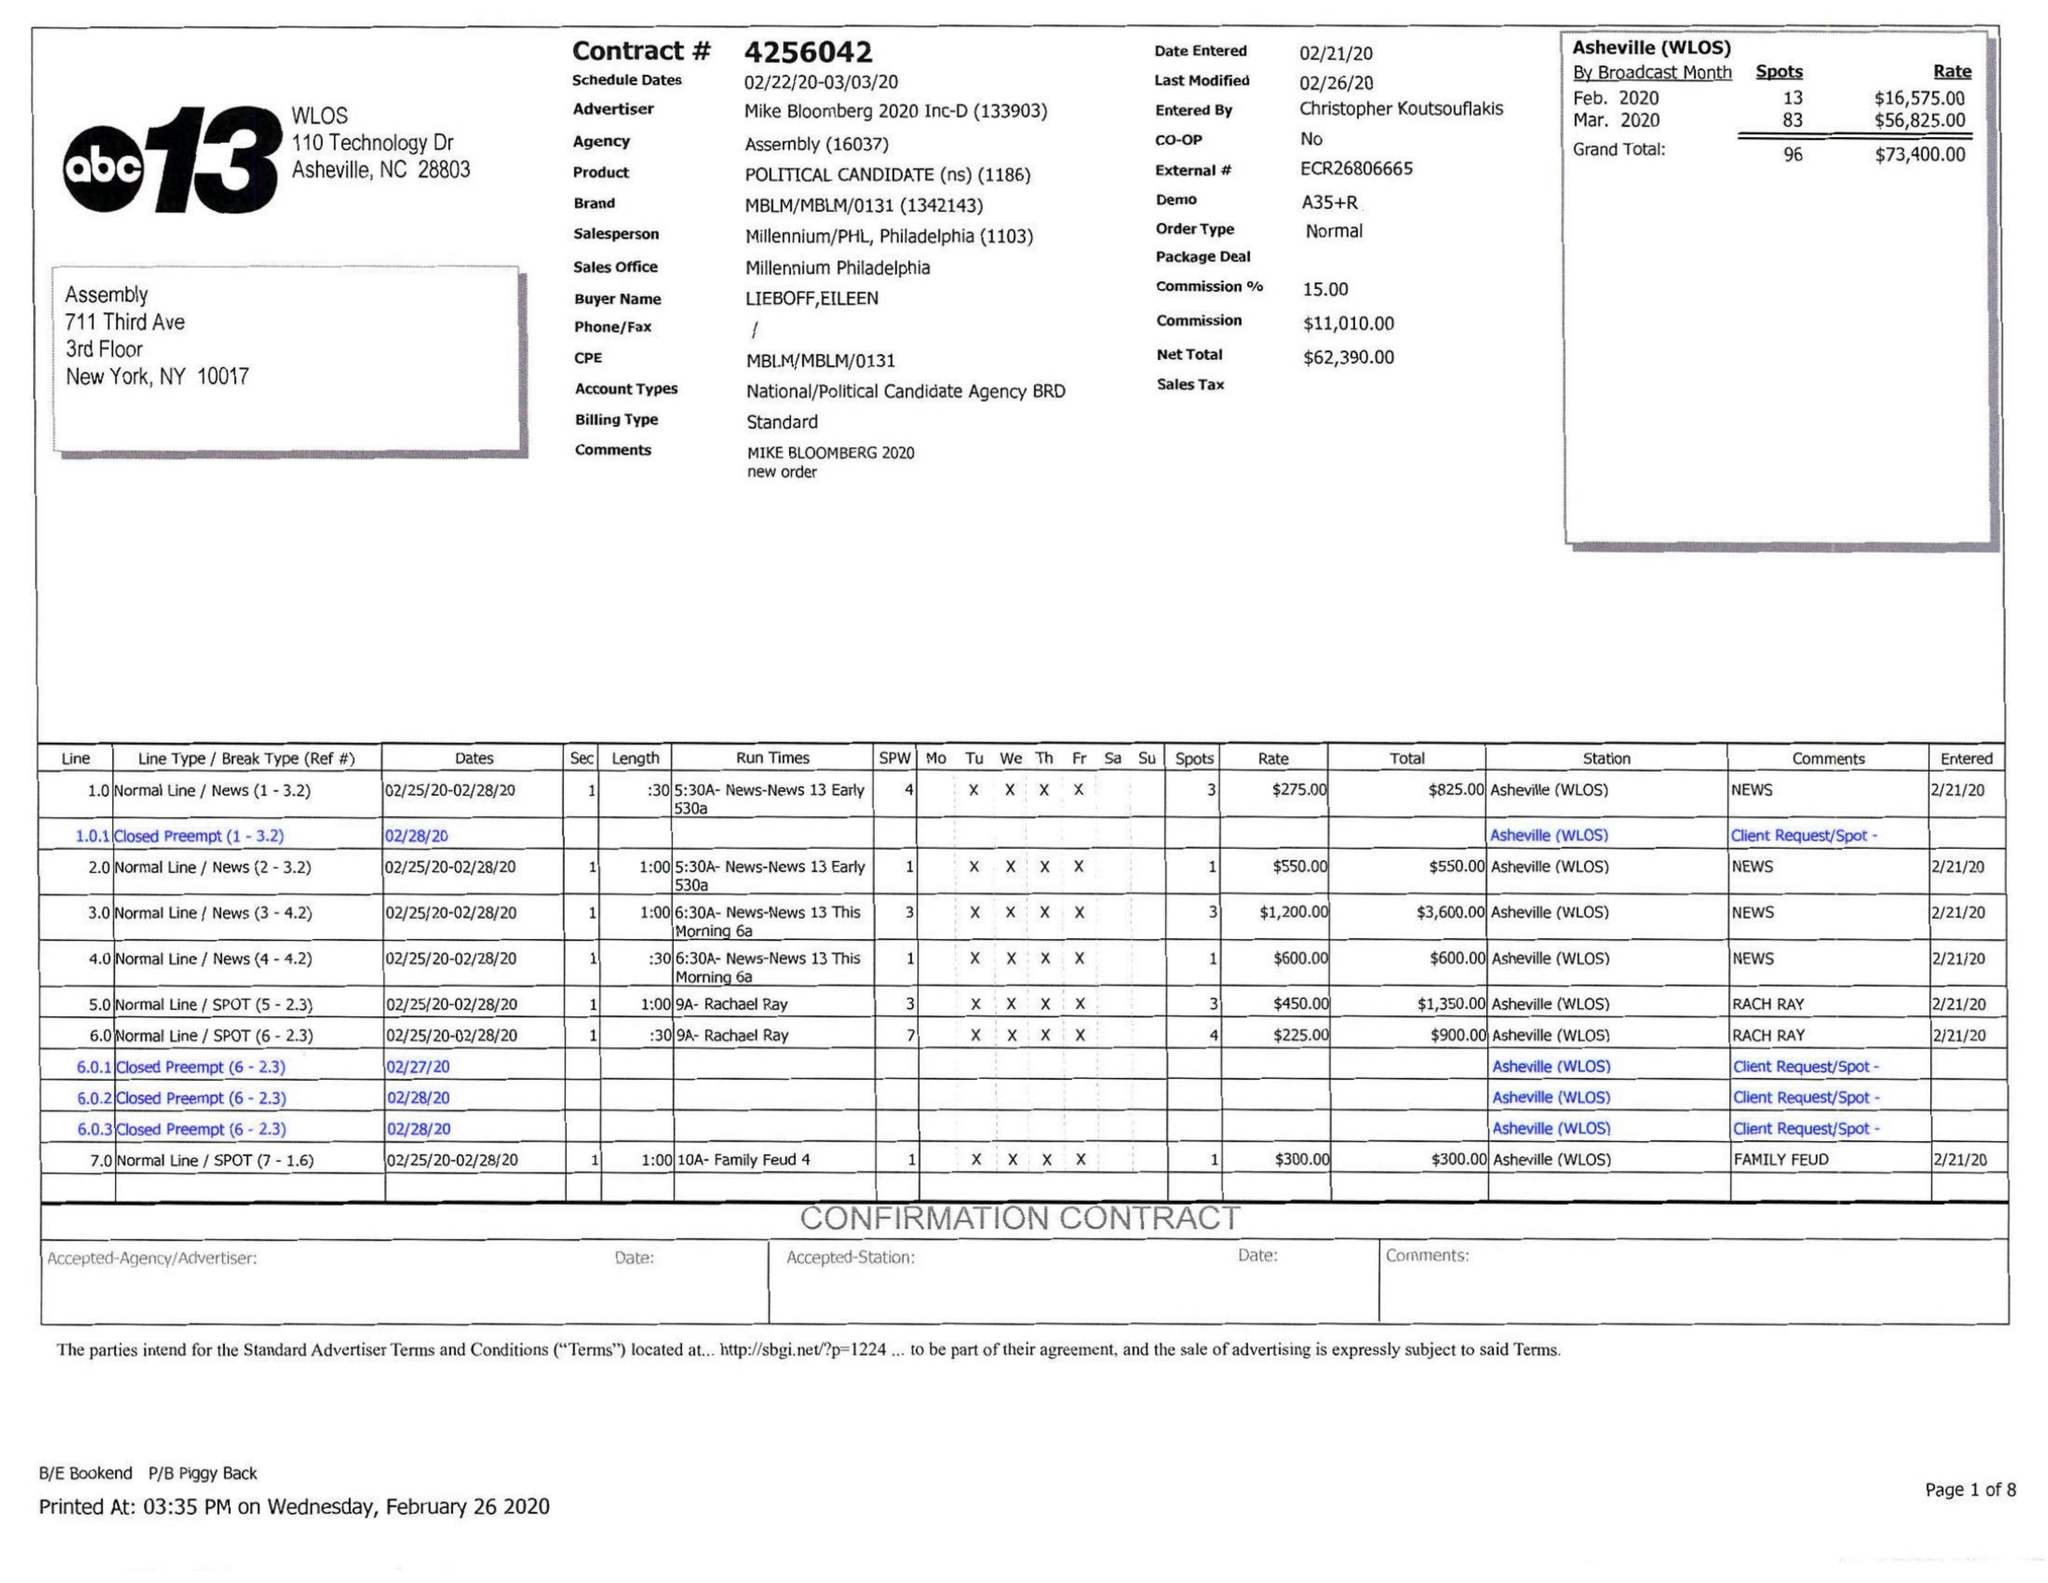What is the value for the advertiser?
Answer the question using a single word or phrase. MIKE BLOOMBERG 2020 INC-D 